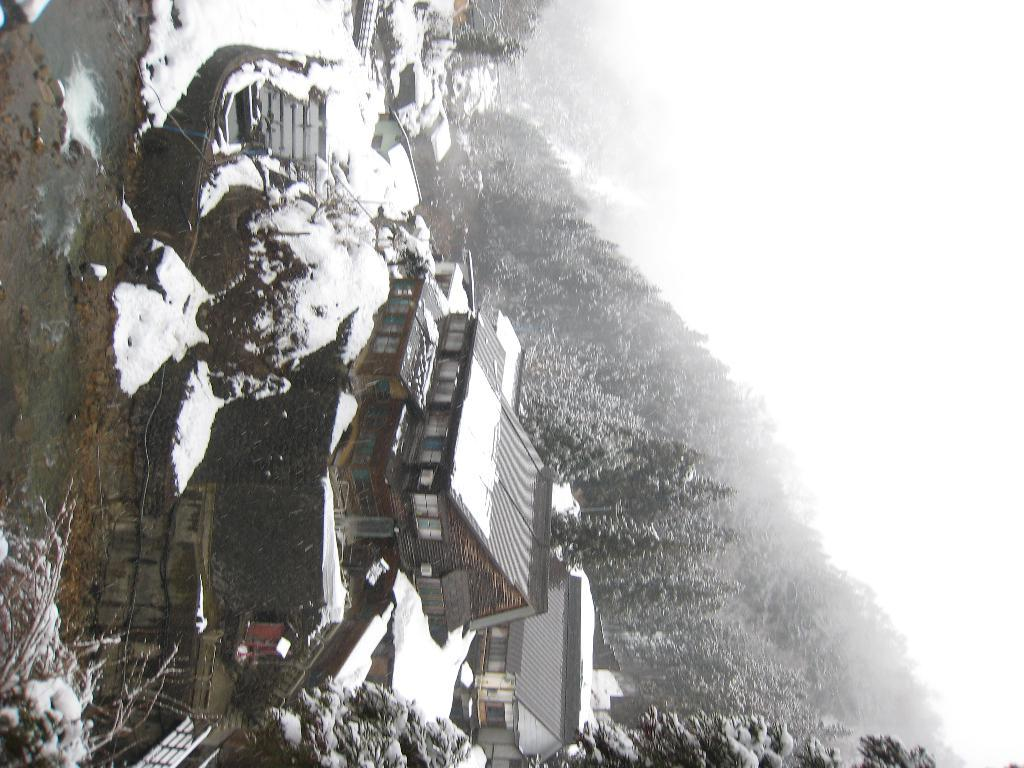What structures are present in the image? There are buildings in the image. What is covering the buildings in the image? The buildings have snow on them. What type of natural environment is visible in the background of the image? There are trees in the background of the image. What is visible in the sky in the background of the image? The sky is visible in the background of the image. What type of stem can be seen growing from the buildings in the image? There is no stem growing from the buildings in the image. What type of exchange is taking place between the buildings in the image? There is no exchange taking place between the buildings in the image. 